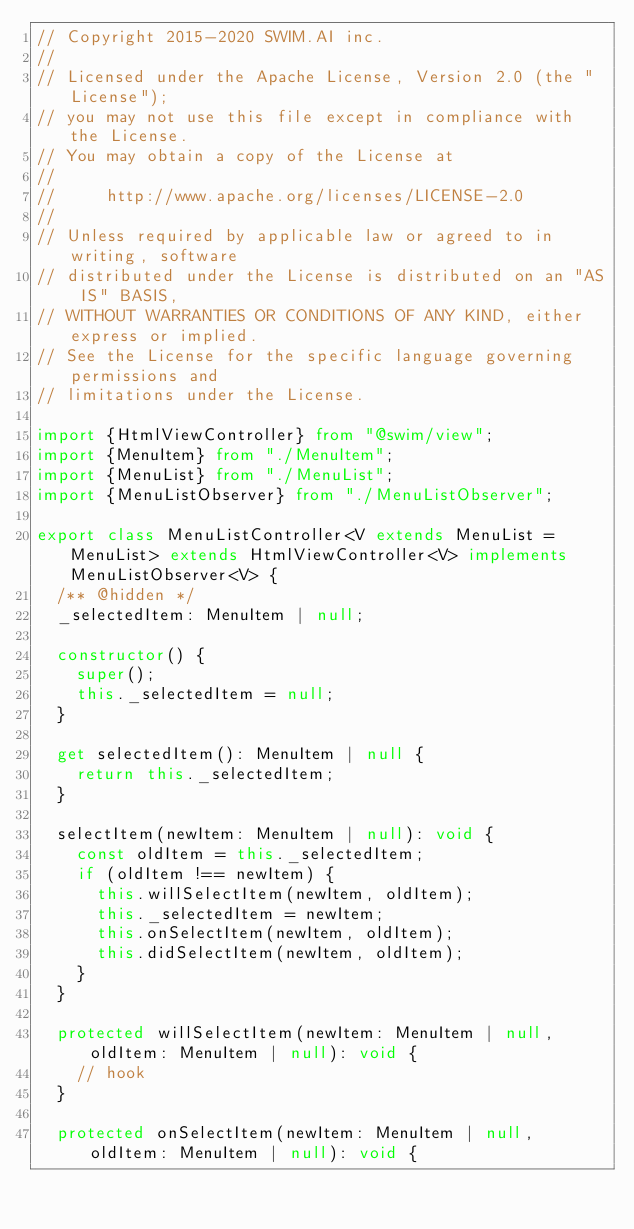<code> <loc_0><loc_0><loc_500><loc_500><_TypeScript_>// Copyright 2015-2020 SWIM.AI inc.
//
// Licensed under the Apache License, Version 2.0 (the "License");
// you may not use this file except in compliance with the License.
// You may obtain a copy of the License at
//
//     http://www.apache.org/licenses/LICENSE-2.0
//
// Unless required by applicable law or agreed to in writing, software
// distributed under the License is distributed on an "AS IS" BASIS,
// WITHOUT WARRANTIES OR CONDITIONS OF ANY KIND, either express or implied.
// See the License for the specific language governing permissions and
// limitations under the License.

import {HtmlViewController} from "@swim/view";
import {MenuItem} from "./MenuItem";
import {MenuList} from "./MenuList";
import {MenuListObserver} from "./MenuListObserver";

export class MenuListController<V extends MenuList = MenuList> extends HtmlViewController<V> implements MenuListObserver<V> {
  /** @hidden */
  _selectedItem: MenuItem | null;

  constructor() {
    super();
    this._selectedItem = null;
  }

  get selectedItem(): MenuItem | null {
    return this._selectedItem;
  }

  selectItem(newItem: MenuItem | null): void {
    const oldItem = this._selectedItem;
    if (oldItem !== newItem) {
      this.willSelectItem(newItem, oldItem);
      this._selectedItem = newItem;
      this.onSelectItem(newItem, oldItem);
      this.didSelectItem(newItem, oldItem);
    }
  }

  protected willSelectItem(newItem: MenuItem | null, oldItem: MenuItem | null): void {
    // hook
  }

  protected onSelectItem(newItem: MenuItem | null, oldItem: MenuItem | null): void {</code> 